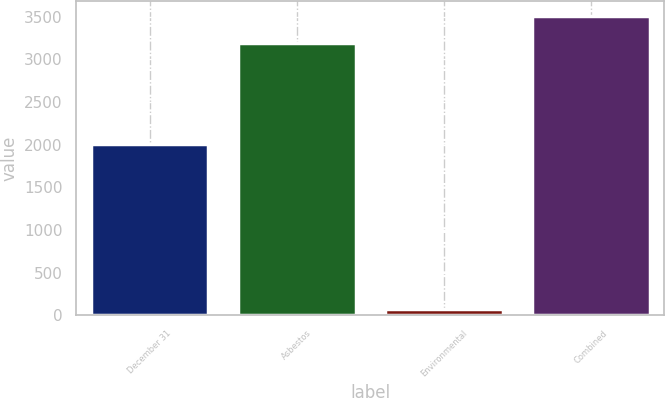<chart> <loc_0><loc_0><loc_500><loc_500><bar_chart><fcel>December 31<fcel>Asbestos<fcel>Environmental<fcel>Combined<nl><fcel>2012<fcel>3193<fcel>75<fcel>3512.3<nl></chart> 